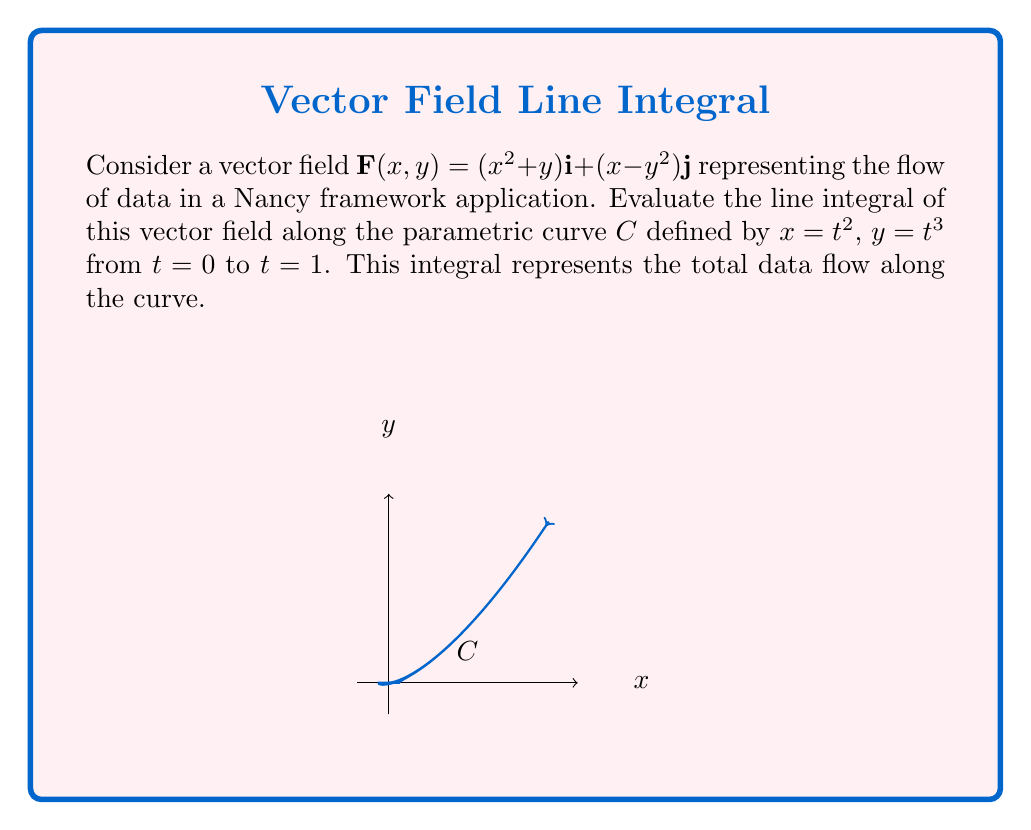Provide a solution to this math problem. To evaluate the line integral, we'll follow these steps:

1) First, we need to express $\mathbf{F}$ in terms of $t$:
   $\mathbf{F}(t) = ((t^2)^2 + t^3)\mathbf{i} + (t^2 - (t^3)^2)\mathbf{j}$
   $\mathbf{F}(t) = (t^4 + t^3)\mathbf{i} + (t^2 - t^6)\mathbf{j}$

2) Next, we need to find $\frac{d\mathbf{r}}{dt}$:
   $\frac{dx}{dt} = 2t$, $\frac{dy}{dt} = 3t^2$
   So, $\frac{d\mathbf{r}}{dt} = 2t\mathbf{i} + 3t^2\mathbf{j}$

3) Now, we can set up the line integral:
   $\int_C \mathbf{F} \cdot d\mathbf{r} = \int_0^1 \mathbf{F}(t) \cdot \frac{d\mathbf{r}}{dt} dt$

4) Let's compute the dot product inside the integral:
   $\mathbf{F}(t) \cdot \frac{d\mathbf{r}}{dt} = (t^4 + t^3)(2t) + (t^2 - t^6)(3t^2)$
   $= 2t^5 + 2t^4 + 3t^4 - 3t^8$

5) Now we can integrate:
   $\int_0^1 (2t^5 + 2t^4 + 3t^4 - 3t^8) dt$
   $= [2\frac{t^6}{6} + 2\frac{t^5}{5} + 3\frac{t^5}{5} - 3\frac{t^9}{9}]_0^1$
   $= (\frac{1}{3} + \frac{2}{5} + \frac{3}{5} - \frac{1}{3}) - 0$
   $= \frac{1}{3} + \frac{2}{5} + \frac{3}{5} - \frac{1}{3}$
   $= 1$

Therefore, the total data flow along the curve is 1 unit.
Answer: $1$ 